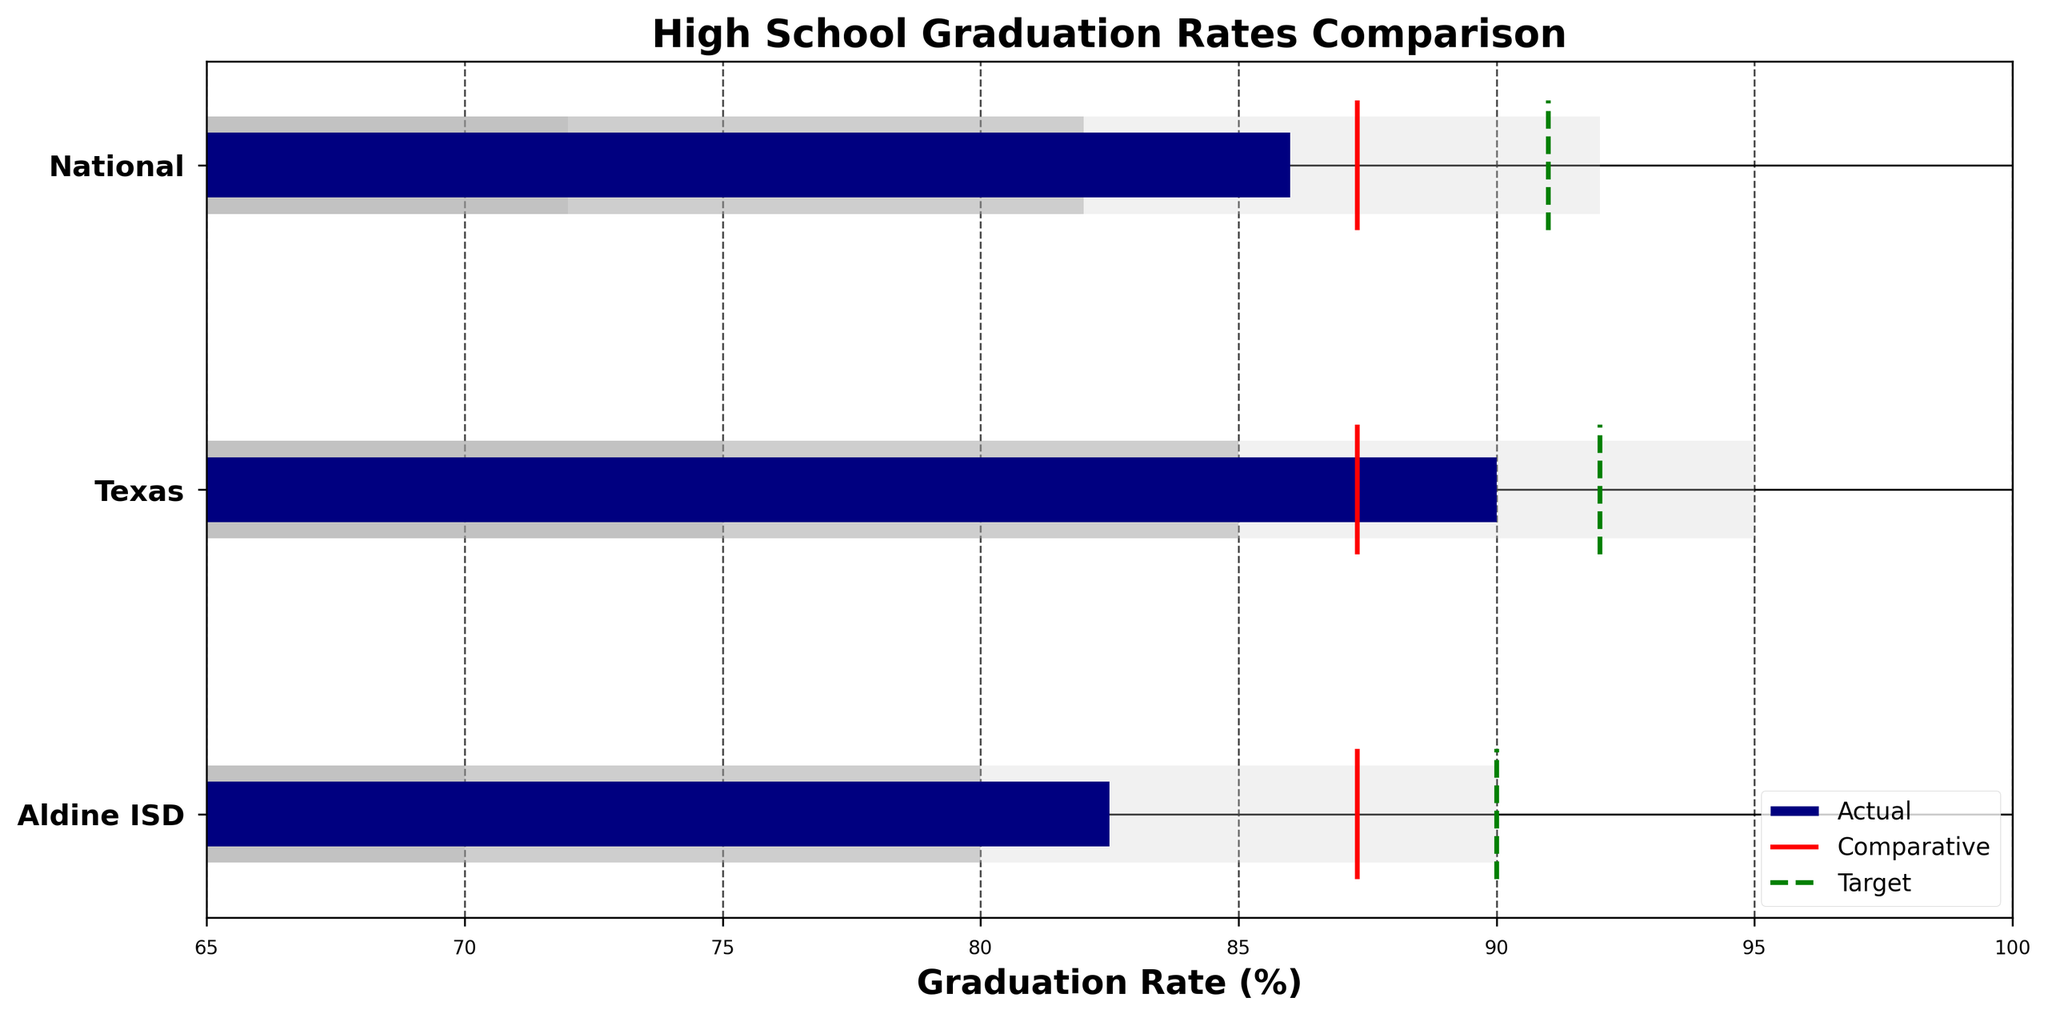What's the title of the chart? The title is displayed at the top of the chart, indicating what the chart represents.
Answer: High School Graduation Rates Comparison How many categories are shown in the chart? The Y-axis labels three categories, indicating the different groups compared in the chart.
Answer: Three What is the actual graduation rate for Aldine ISD? The blue bar corresponding to Aldine ISD reaches the value of 82.5 on the X-axis.
Answer: 82.5% What target graduation rate is set for Texas? The green dashed line for Texas extends to the value of 92 on the X-axis.
Answer: 92% Which category has the highest actual graduation rate? The blue bar that extends furthest to the right among Texas, Aldine ISD, and National indicates the highest actual graduation rate. Texas shows the value of 90 on the X-axis.
Answer: Texas What is the difference between the actual and comparative graduation rates for Aldine ISD? The actual value for Aldine ISD is 82.5, and the comparative value is 87.3. Subtracting the actual from the comparative gives the difference.
Answer: 4.8 Is the Aldine ISD actual graduation rate higher or lower than the national average? Comparing the lengths of the blue bars for Aldine ISD and National shows that Aldine ISD’s actual graduation rate (82.5) is lower than the National rate (86).
Answer: Lower Which category has the smallest difference between its actual graduation rate and its target rate? Subtract the target rate from the actual rate for each category: Aldine ISD (90 - 82.5 = 7.5), Texas (92 - 90 = 2), National (91 - 86 = 5). The smallest difference is for Texas.
Answer: Texas What range is considered "adequate" for Aldine ISD? The medium grey bar indicates the adequate range for Aldine ISD, represented by Range2 in the dataset, starting at 80 and ending at 90.
Answer: 80-90 What is the comparative value used for in the chart? The thin red line marks the comparative value; it's a benchmark for comparing actual graduation rates showing a consistent value of 87.3 across all categories.
Answer: 87.3 